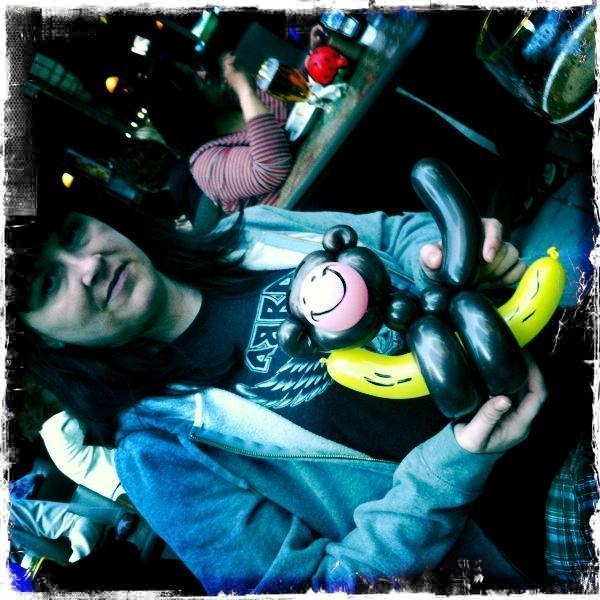How many wine glasses are in the picture?
Give a very brief answer. 2. How many dining tables can be seen?
Give a very brief answer. 1. How many people are in the photo?
Give a very brief answer. 3. How many buses are there?
Give a very brief answer. 0. 